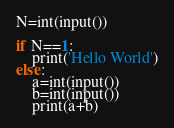<code> <loc_0><loc_0><loc_500><loc_500><_Python_>N=int(input())

if N==1:
    print('Hello World')
else:
    a=int(input())
    b=int(input())
    print(a+b)</code> 